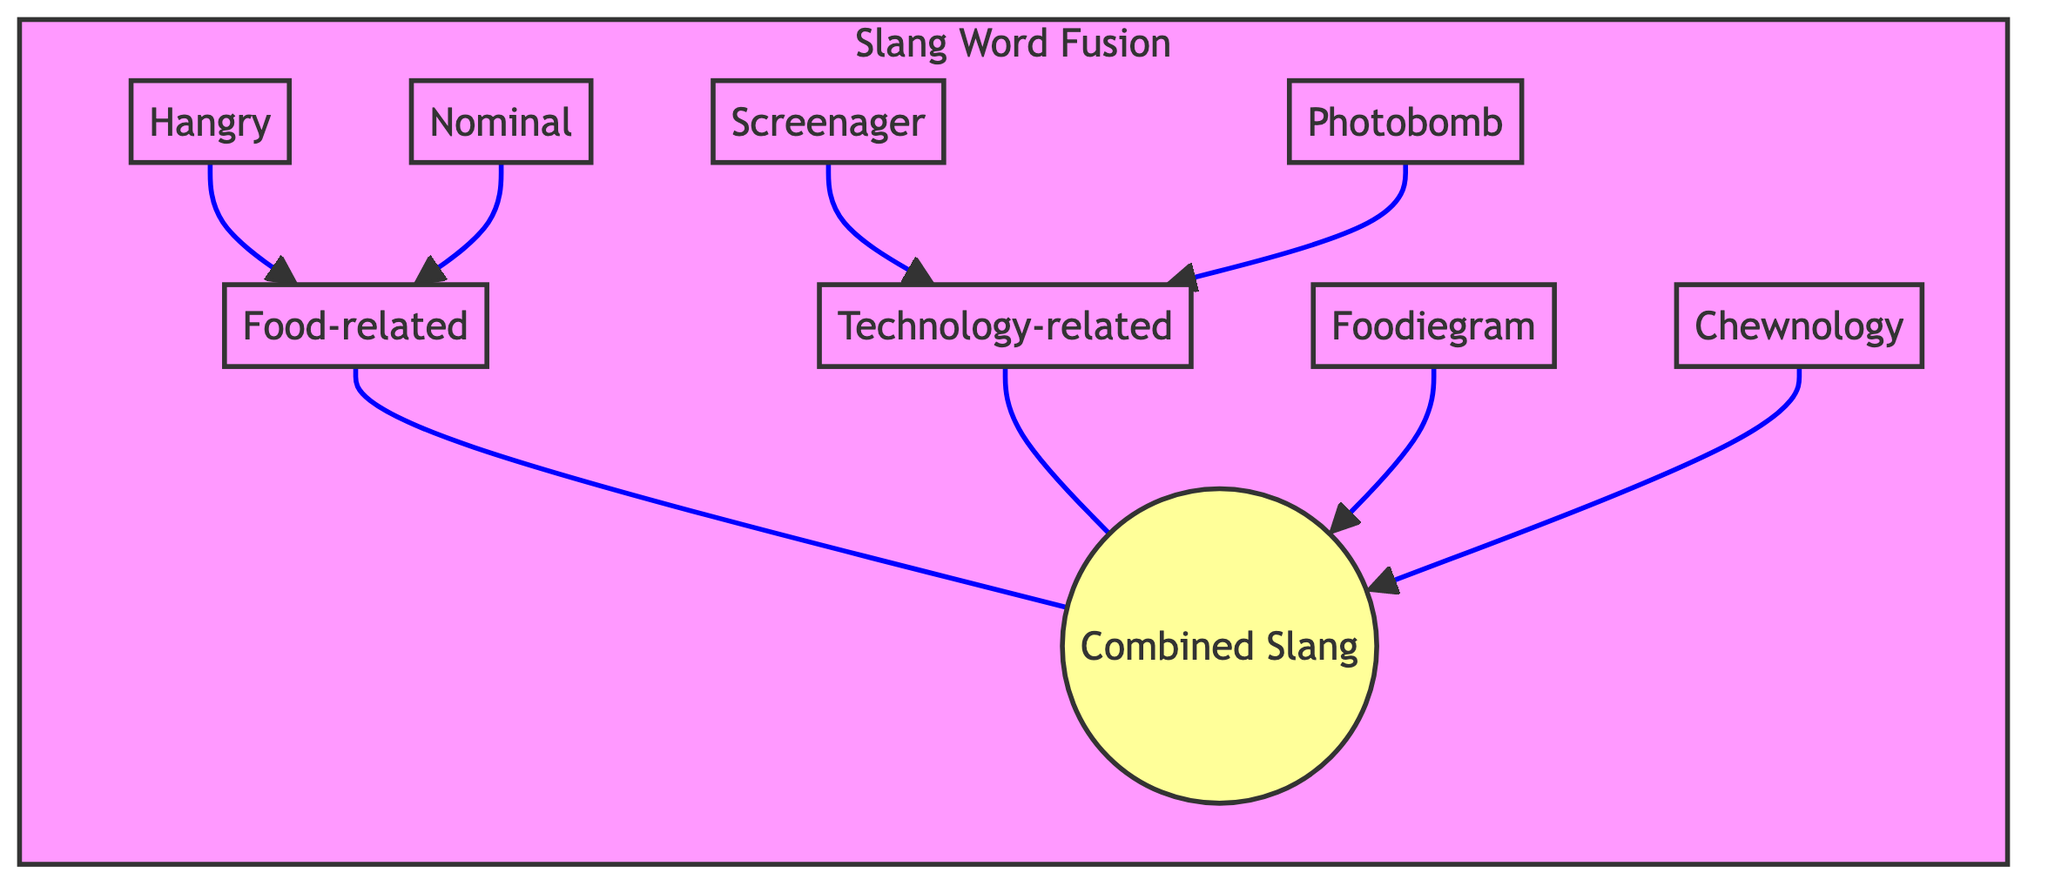What are the two main categories in the diagram? The diagram showcases two main categories, labeled "Food-related" and "Technology-related," indicating the sources of the slang words.
Answer: Food-related, Technology-related How many combined slang words are shown in the diagram? The diagram includes two combined slang words under the "Combined Slang" section, which are "Foodiegram" and "Chewnology."
Answer: 2 Which slang word is linked to "Food-related"? The slang word "Hangry" is connected to the "Food-related" category, showing that it belongs to this linguistic characteristic.
Answer: Hangry What slang word is combined from both categories? The slang word "Foodiegram" is an example of a combination of "Food-related" and "Technology-related," representing the fusion of both categories.
Answer: Foodiegram Which category includes "Screenager"? The "Technology-related" category contains the slang word "Screenager," indicating its source and linguistic origin.
Answer: Technology-related How many edges connect the "Food-related" category to its slang words? There are two edges linking the "Food-related" category to its associated slang words, "Hangry" and "Nominal."
Answer: 2 What color represents the "Technology-related" category? The "Technology-related" category is represented using a light red color (#ffe6e6) in the diagram, differentiating it visually from the other category.
Answer: light red Which slang term appears in both categories? The combined slang word "Chewnology" incorporates elements from both the "Food-related" and "Technology-related" categories.
Answer: Chewnology What is the label of the combined slang section? The section that showcases new slang words formed from fusions is labeled "Combined Slang" in the diagram.
Answer: Combined Slang 